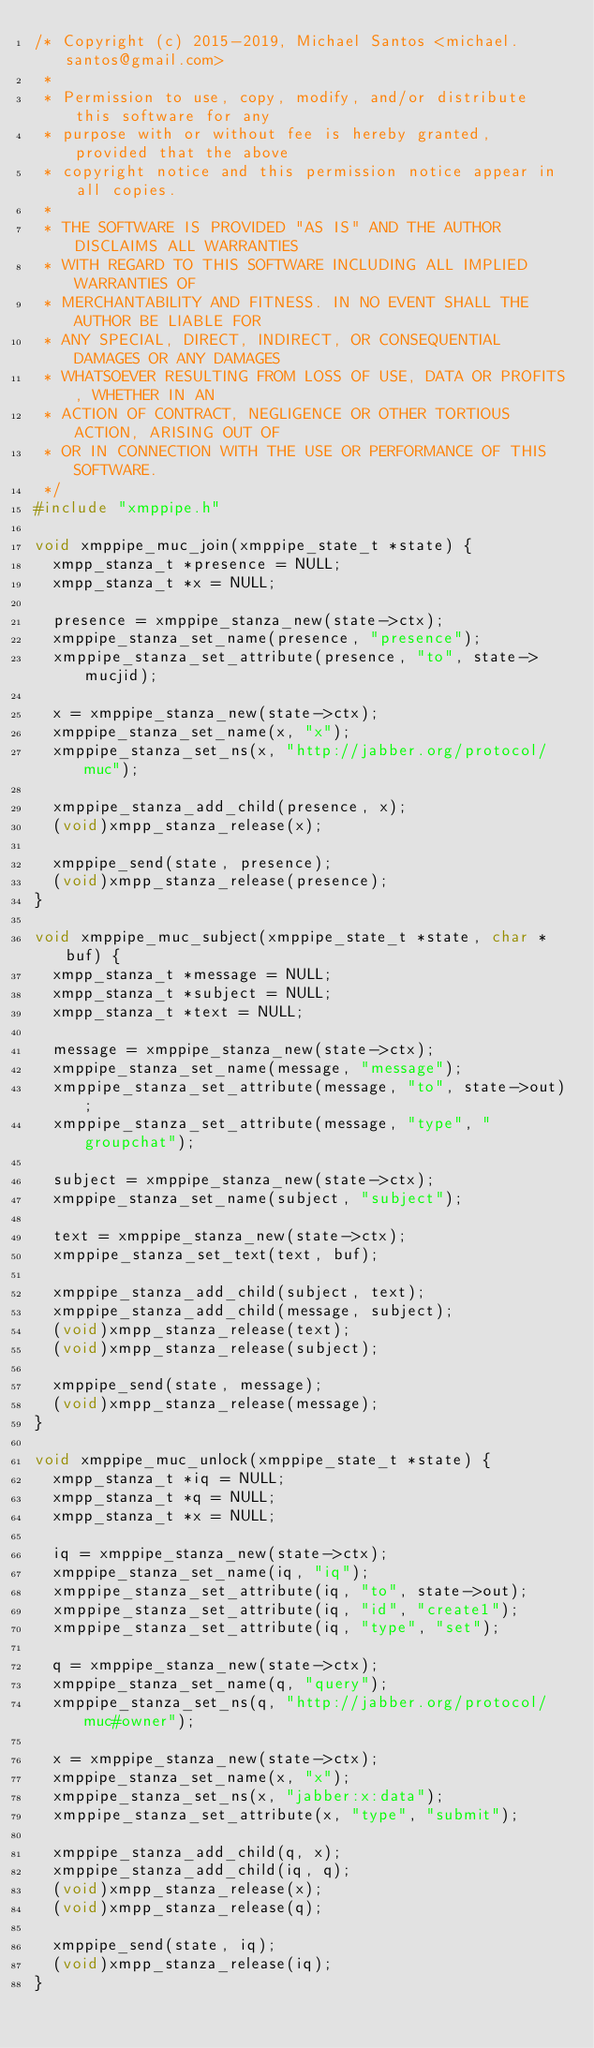<code> <loc_0><loc_0><loc_500><loc_500><_C_>/* Copyright (c) 2015-2019, Michael Santos <michael.santos@gmail.com>
 *
 * Permission to use, copy, modify, and/or distribute this software for any
 * purpose with or without fee is hereby granted, provided that the above
 * copyright notice and this permission notice appear in all copies.
 *
 * THE SOFTWARE IS PROVIDED "AS IS" AND THE AUTHOR DISCLAIMS ALL WARRANTIES
 * WITH REGARD TO THIS SOFTWARE INCLUDING ALL IMPLIED WARRANTIES OF
 * MERCHANTABILITY AND FITNESS. IN NO EVENT SHALL THE AUTHOR BE LIABLE FOR
 * ANY SPECIAL, DIRECT, INDIRECT, OR CONSEQUENTIAL DAMAGES OR ANY DAMAGES
 * WHATSOEVER RESULTING FROM LOSS OF USE, DATA OR PROFITS, WHETHER IN AN
 * ACTION OF CONTRACT, NEGLIGENCE OR OTHER TORTIOUS ACTION, ARISING OUT OF
 * OR IN CONNECTION WITH THE USE OR PERFORMANCE OF THIS SOFTWARE.
 */
#include "xmppipe.h"

void xmppipe_muc_join(xmppipe_state_t *state) {
  xmpp_stanza_t *presence = NULL;
  xmpp_stanza_t *x = NULL;

  presence = xmppipe_stanza_new(state->ctx);
  xmppipe_stanza_set_name(presence, "presence");
  xmppipe_stanza_set_attribute(presence, "to", state->mucjid);

  x = xmppipe_stanza_new(state->ctx);
  xmppipe_stanza_set_name(x, "x");
  xmppipe_stanza_set_ns(x, "http://jabber.org/protocol/muc");

  xmppipe_stanza_add_child(presence, x);
  (void)xmpp_stanza_release(x);

  xmppipe_send(state, presence);
  (void)xmpp_stanza_release(presence);
}

void xmppipe_muc_subject(xmppipe_state_t *state, char *buf) {
  xmpp_stanza_t *message = NULL;
  xmpp_stanza_t *subject = NULL;
  xmpp_stanza_t *text = NULL;

  message = xmppipe_stanza_new(state->ctx);
  xmppipe_stanza_set_name(message, "message");
  xmppipe_stanza_set_attribute(message, "to", state->out);
  xmppipe_stanza_set_attribute(message, "type", "groupchat");

  subject = xmppipe_stanza_new(state->ctx);
  xmppipe_stanza_set_name(subject, "subject");

  text = xmppipe_stanza_new(state->ctx);
  xmppipe_stanza_set_text(text, buf);

  xmppipe_stanza_add_child(subject, text);
  xmppipe_stanza_add_child(message, subject);
  (void)xmpp_stanza_release(text);
  (void)xmpp_stanza_release(subject);

  xmppipe_send(state, message);
  (void)xmpp_stanza_release(message);
}

void xmppipe_muc_unlock(xmppipe_state_t *state) {
  xmpp_stanza_t *iq = NULL;
  xmpp_stanza_t *q = NULL;
  xmpp_stanza_t *x = NULL;

  iq = xmppipe_stanza_new(state->ctx);
  xmppipe_stanza_set_name(iq, "iq");
  xmppipe_stanza_set_attribute(iq, "to", state->out);
  xmppipe_stanza_set_attribute(iq, "id", "create1");
  xmppipe_stanza_set_attribute(iq, "type", "set");

  q = xmppipe_stanza_new(state->ctx);
  xmppipe_stanza_set_name(q, "query");
  xmppipe_stanza_set_ns(q, "http://jabber.org/protocol/muc#owner");

  x = xmppipe_stanza_new(state->ctx);
  xmppipe_stanza_set_name(x, "x");
  xmppipe_stanza_set_ns(x, "jabber:x:data");
  xmppipe_stanza_set_attribute(x, "type", "submit");

  xmppipe_stanza_add_child(q, x);
  xmppipe_stanza_add_child(iq, q);
  (void)xmpp_stanza_release(x);
  (void)xmpp_stanza_release(q);

  xmppipe_send(state, iq);
  (void)xmpp_stanza_release(iq);
}
</code> 